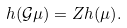<formula> <loc_0><loc_0><loc_500><loc_500>h ( \mathcal { G } \mu ) = Z { h ( \mu ) } .</formula> 